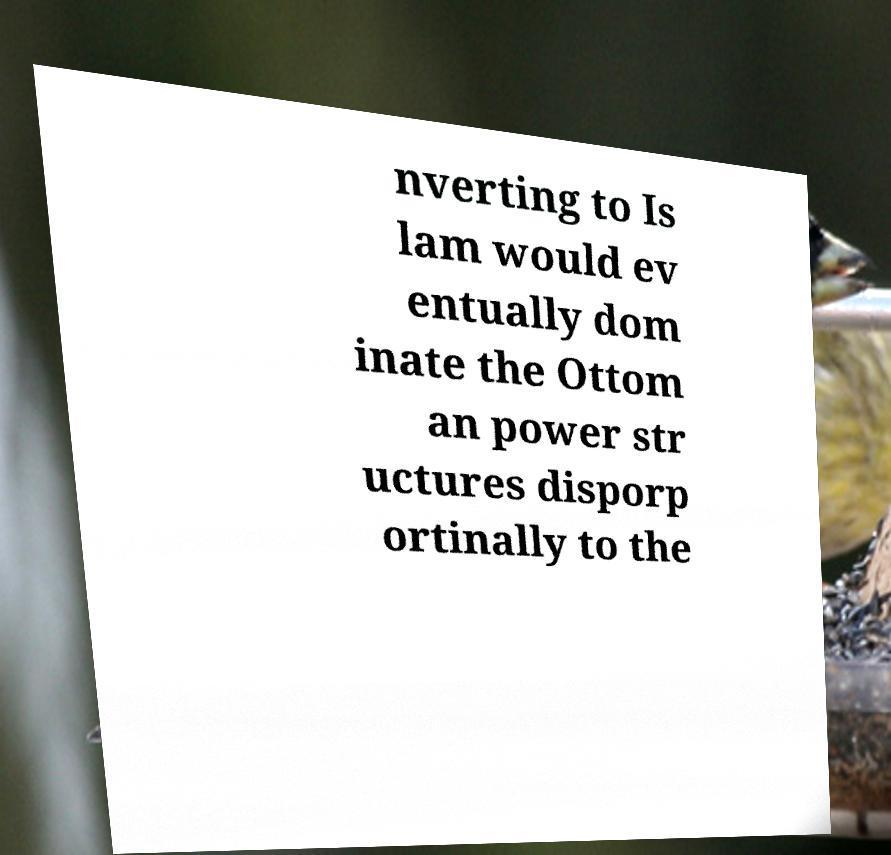Could you assist in decoding the text presented in this image and type it out clearly? nverting to Is lam would ev entually dom inate the Ottom an power str uctures disporp ortinally to the 